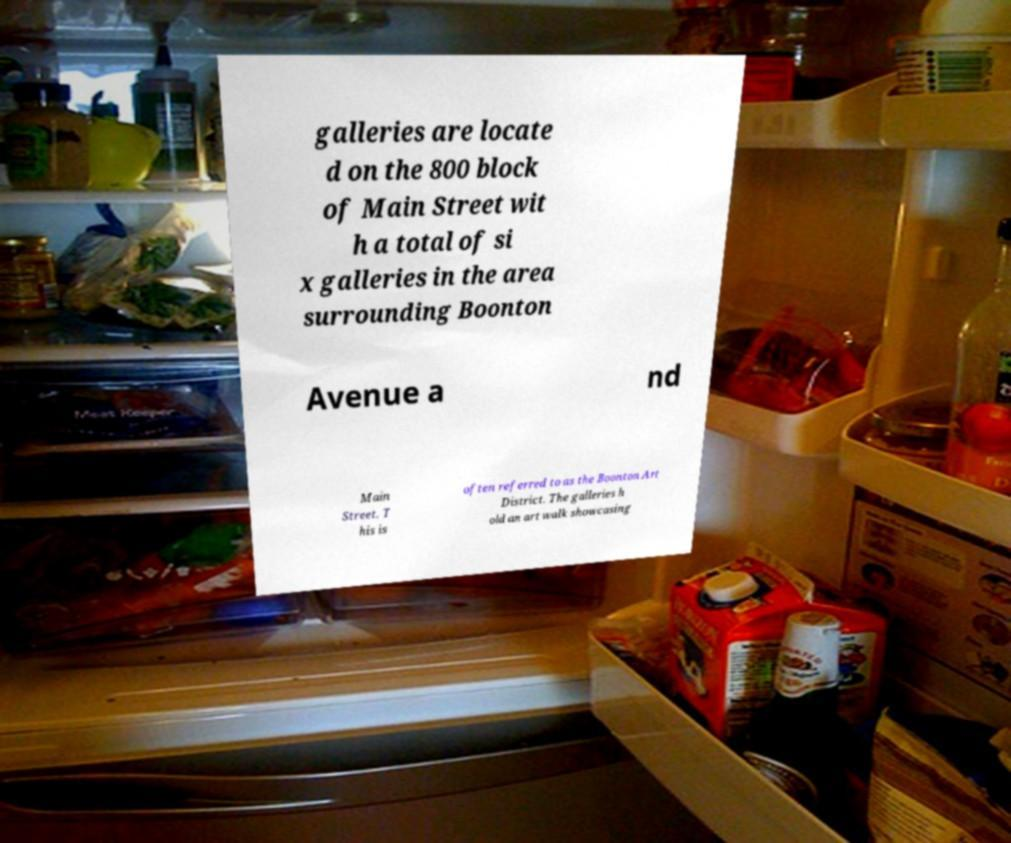Can you read and provide the text displayed in the image?This photo seems to have some interesting text. Can you extract and type it out for me? galleries are locate d on the 800 block of Main Street wit h a total of si x galleries in the area surrounding Boonton Avenue a nd Main Street. T his is often referred to as the Boonton Art District. The galleries h old an art walk showcasing 